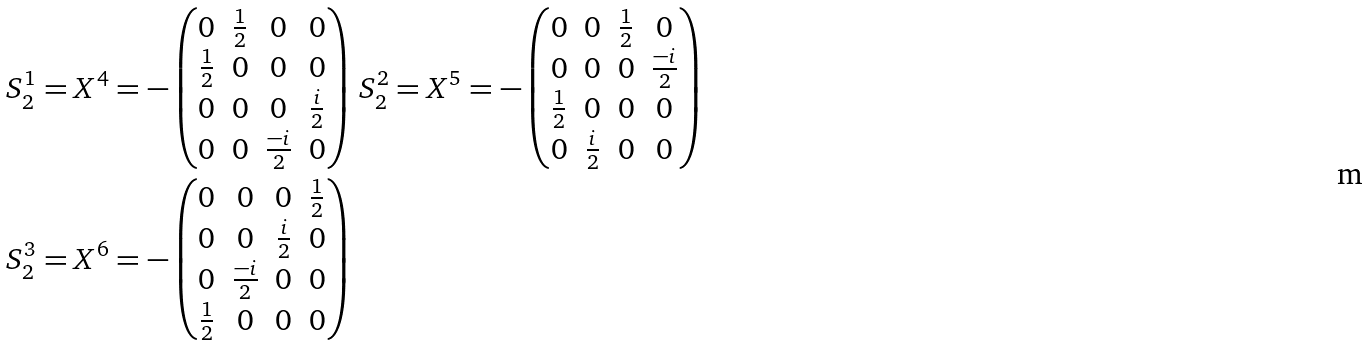Convert formula to latex. <formula><loc_0><loc_0><loc_500><loc_500>& S ^ { 1 } _ { 2 } = X ^ { 4 } = - \begin{pmatrix} 0 & \frac { 1 } { 2 } & 0 & 0 \\ \frac { 1 } { 2 } & 0 & 0 & 0 \\ 0 & 0 & 0 & \frac { i } { 2 } \\ 0 & 0 & \frac { - i } { 2 } & 0 \end{pmatrix} \, S ^ { 2 } _ { 2 } = X ^ { 5 } = - \begin{pmatrix} 0 & 0 & \frac { 1 } { 2 } & 0 \\ 0 & 0 & 0 & \frac { - i } { 2 } \\ \frac { 1 } { 2 } & 0 & 0 & 0 \\ 0 & \frac { i } { 2 } & 0 & 0 \end{pmatrix} \\ & S ^ { 3 } _ { 2 } = X ^ { 6 } = - \begin{pmatrix} 0 & 0 & 0 & \frac { 1 } { 2 } \\ 0 & 0 & \frac { i } { 2 } & 0 \\ 0 & \frac { - i } { 2 } & 0 & 0 \\ \frac { 1 } { 2 } & 0 & 0 & 0 \end{pmatrix}</formula> 